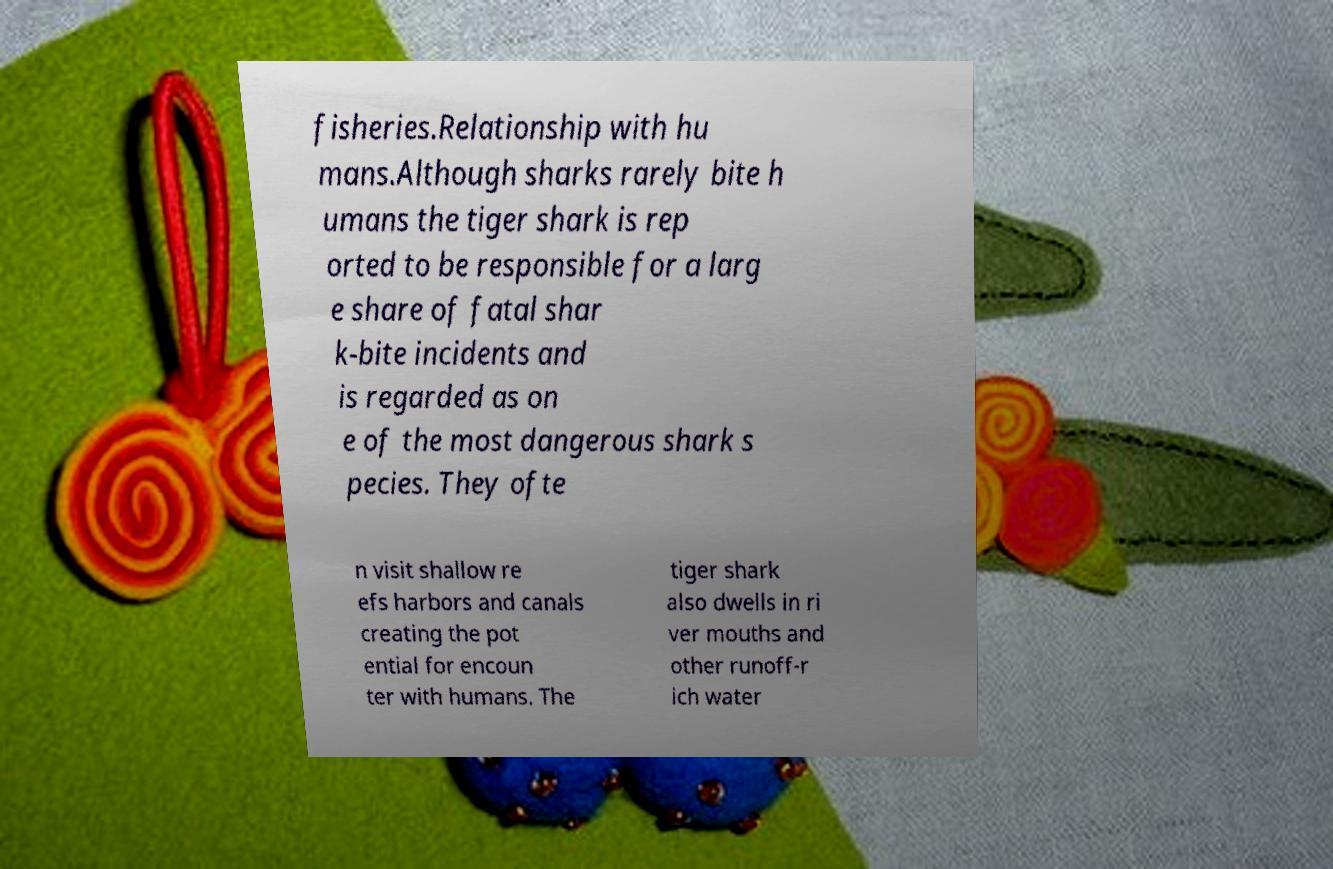Can you accurately transcribe the text from the provided image for me? fisheries.Relationship with hu mans.Although sharks rarely bite h umans the tiger shark is rep orted to be responsible for a larg e share of fatal shar k-bite incidents and is regarded as on e of the most dangerous shark s pecies. They ofte n visit shallow re efs harbors and canals creating the pot ential for encoun ter with humans. The tiger shark also dwells in ri ver mouths and other runoff-r ich water 